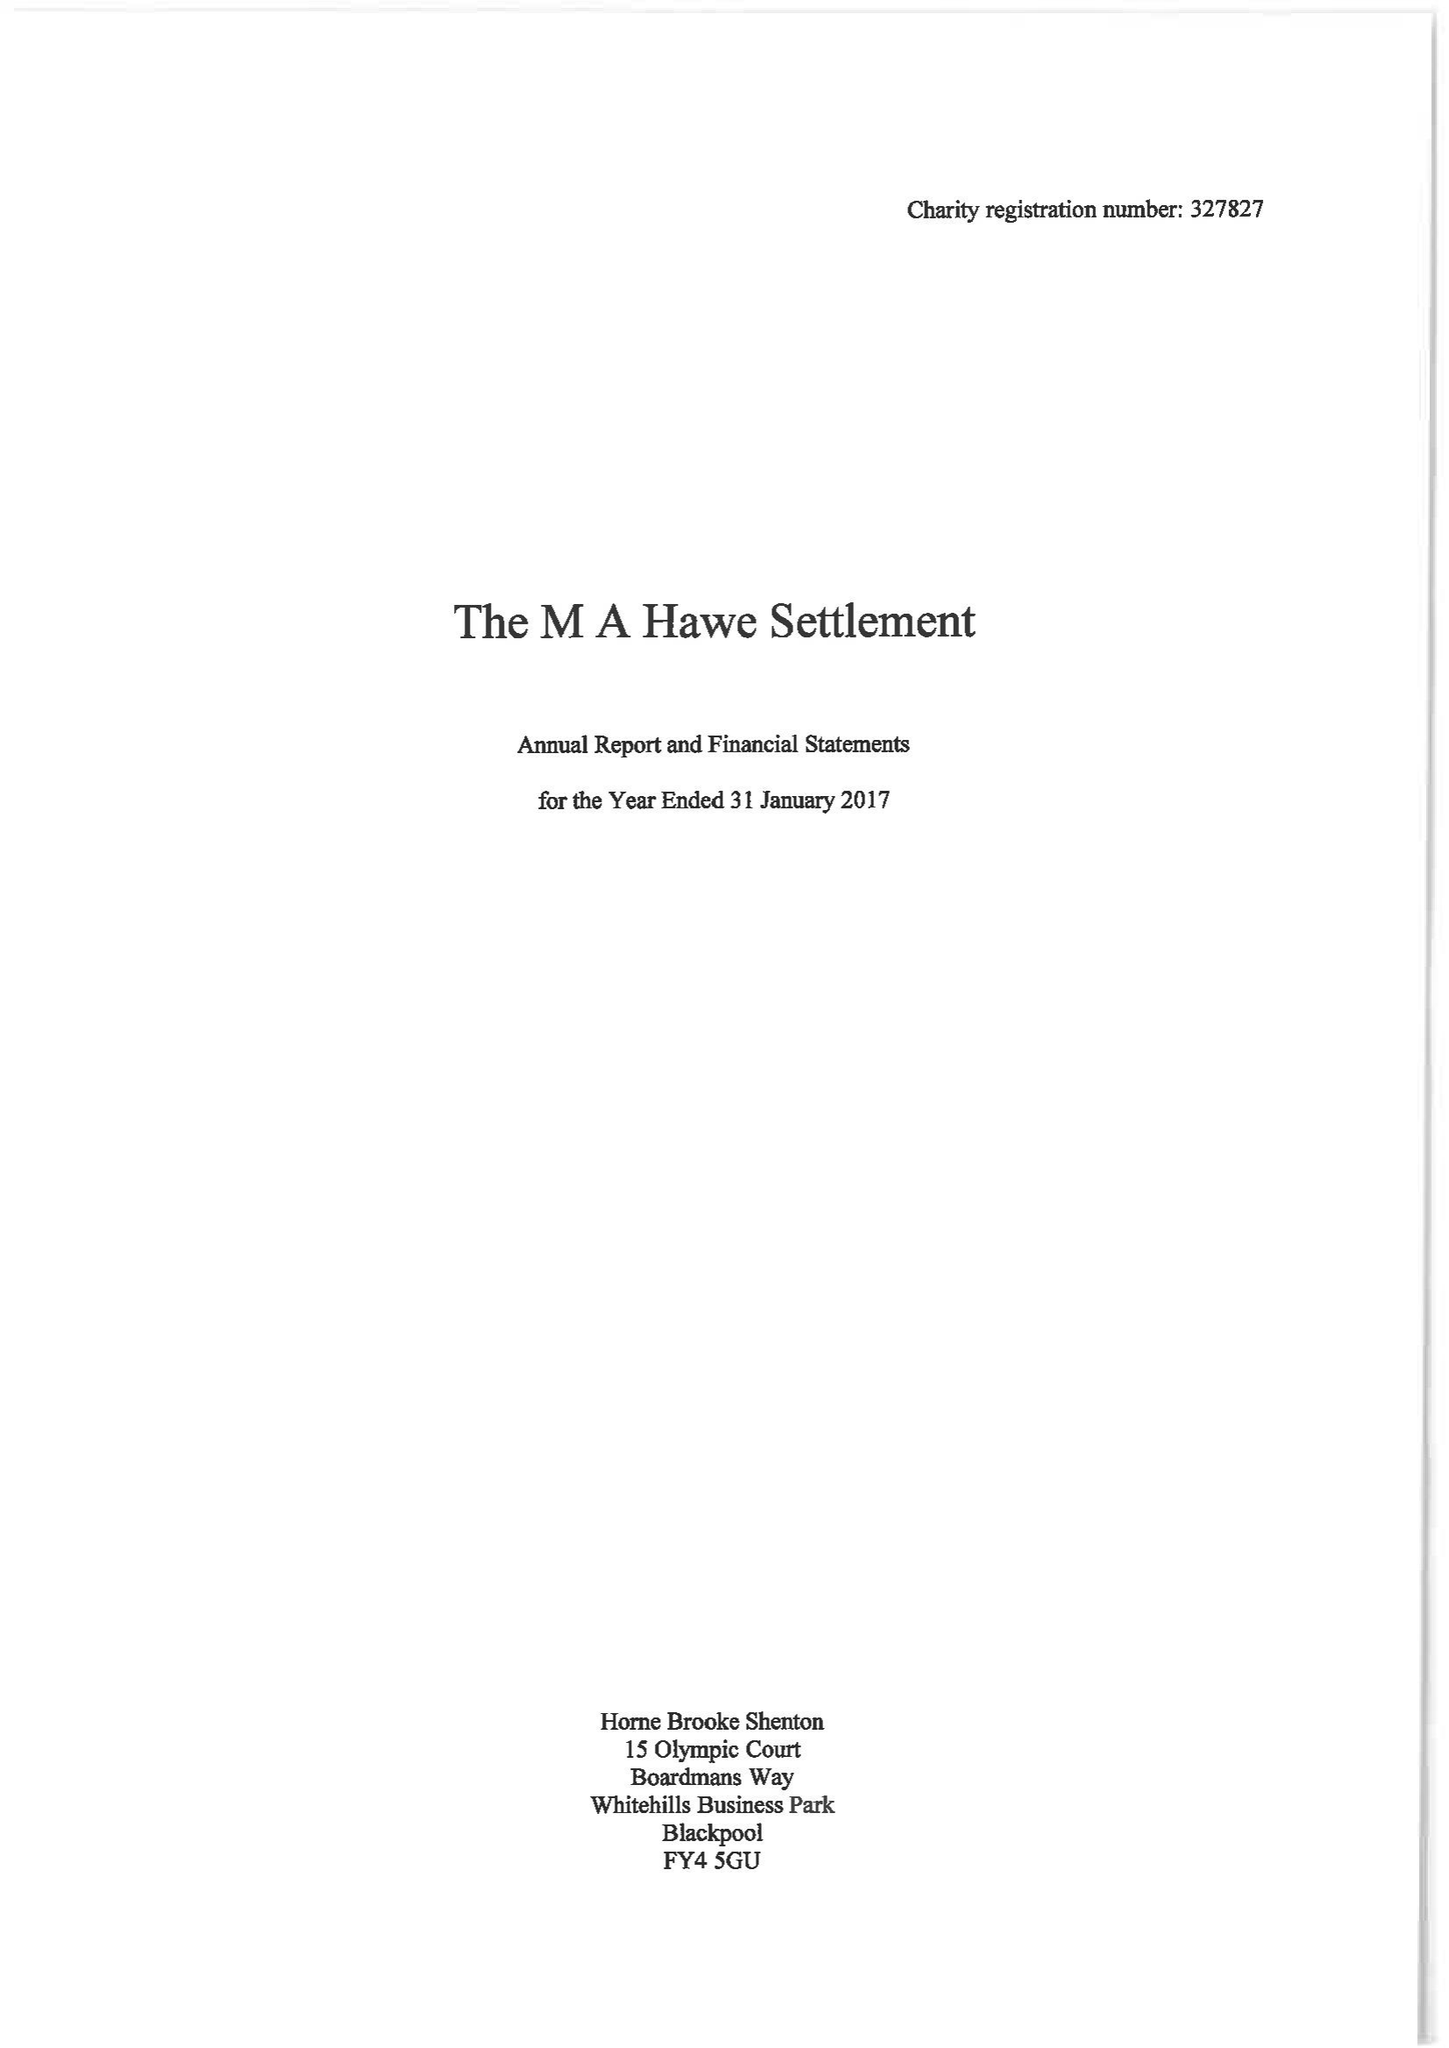What is the value for the spending_annually_in_british_pounds?
Answer the question using a single word or phrase. 190425.00 